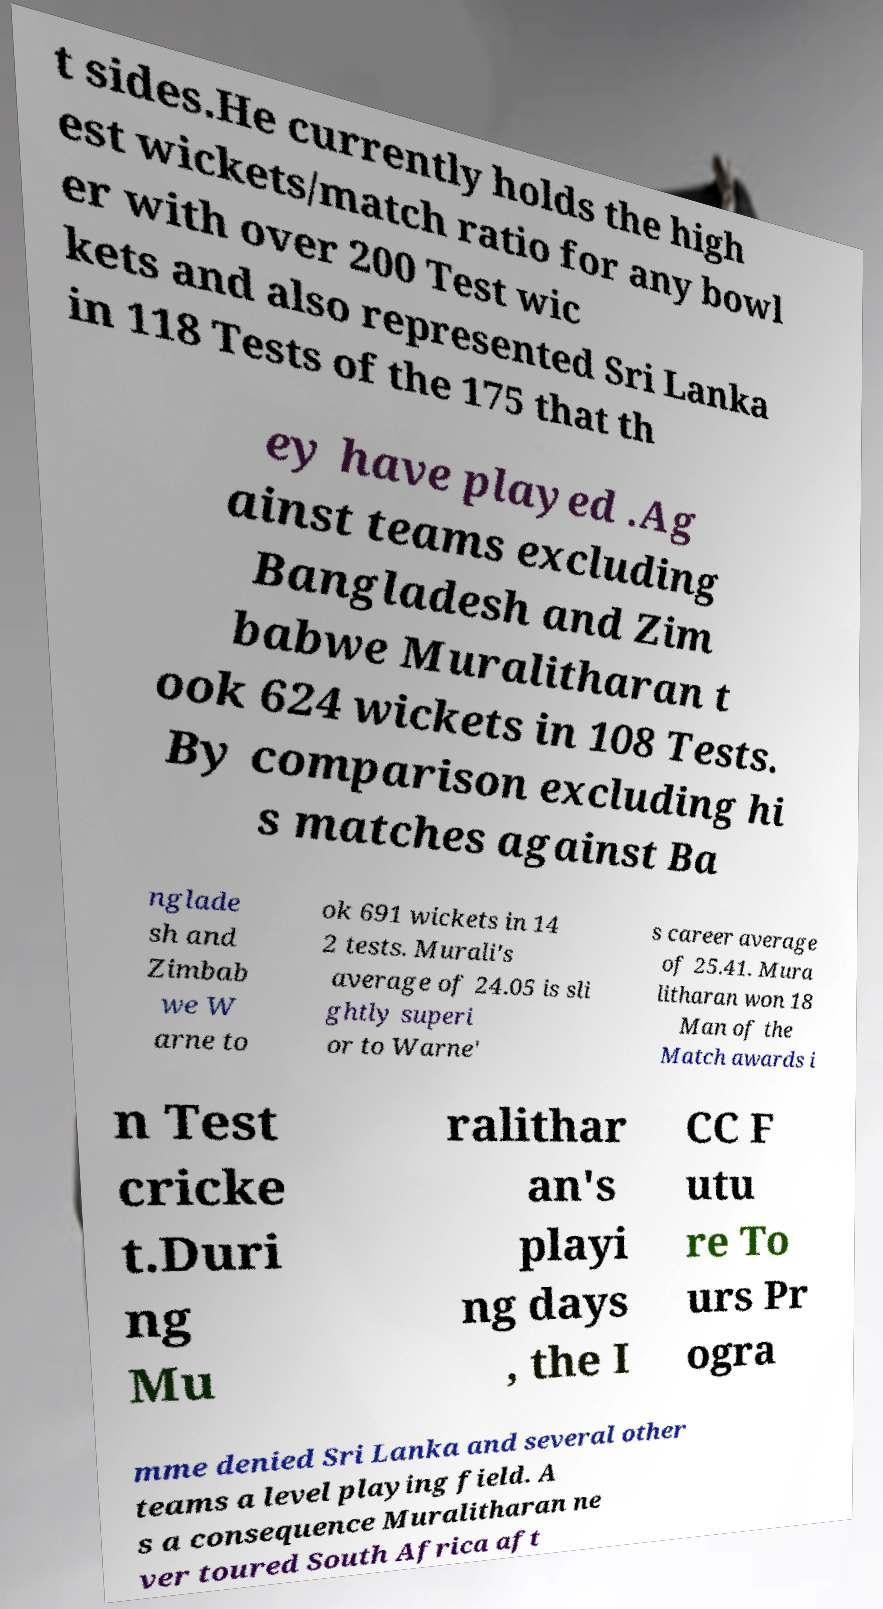Could you assist in decoding the text presented in this image and type it out clearly? t sides.He currently holds the high est wickets/match ratio for any bowl er with over 200 Test wic kets and also represented Sri Lanka in 118 Tests of the 175 that th ey have played .Ag ainst teams excluding Bangladesh and Zim babwe Muralitharan t ook 624 wickets in 108 Tests. By comparison excluding hi s matches against Ba nglade sh and Zimbab we W arne to ok 691 wickets in 14 2 tests. Murali's average of 24.05 is sli ghtly superi or to Warne' s career average of 25.41. Mura litharan won 18 Man of the Match awards i n Test cricke t.Duri ng Mu ralithar an's playi ng days , the I CC F utu re To urs Pr ogra mme denied Sri Lanka and several other teams a level playing field. A s a consequence Muralitharan ne ver toured South Africa aft 